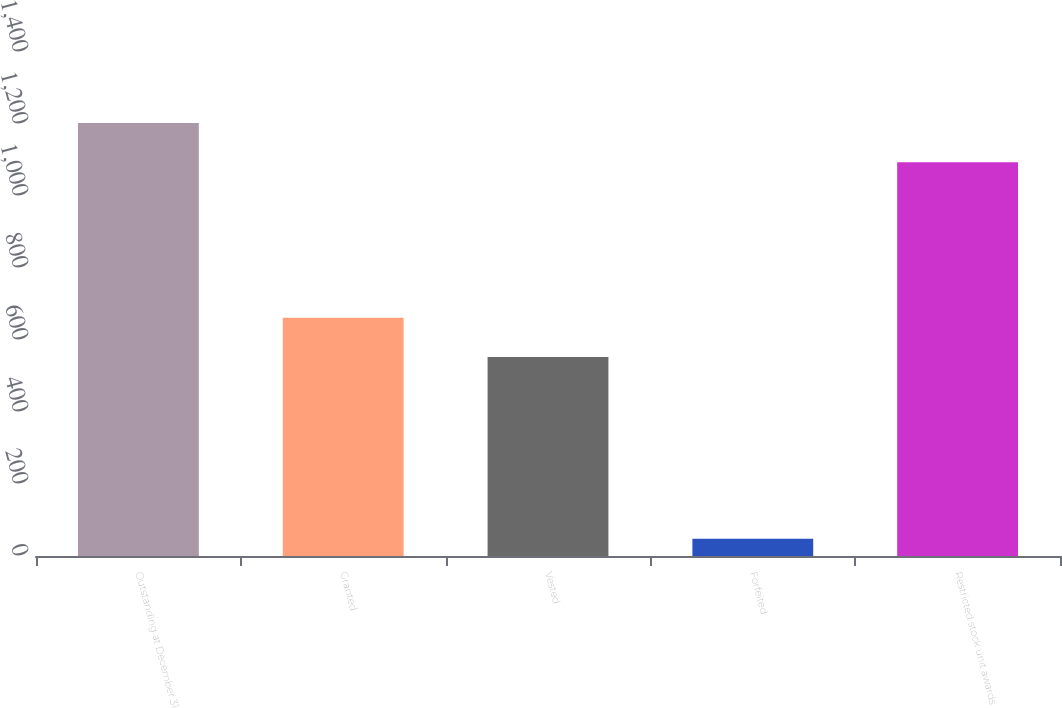<chart> <loc_0><loc_0><loc_500><loc_500><bar_chart><fcel>Outstanding at December 31<fcel>Granted<fcel>Vested<fcel>Forfeited<fcel>Restricted stock unit awards<nl><fcel>1203.1<fcel>662.1<fcel>553<fcel>48<fcel>1094<nl></chart> 